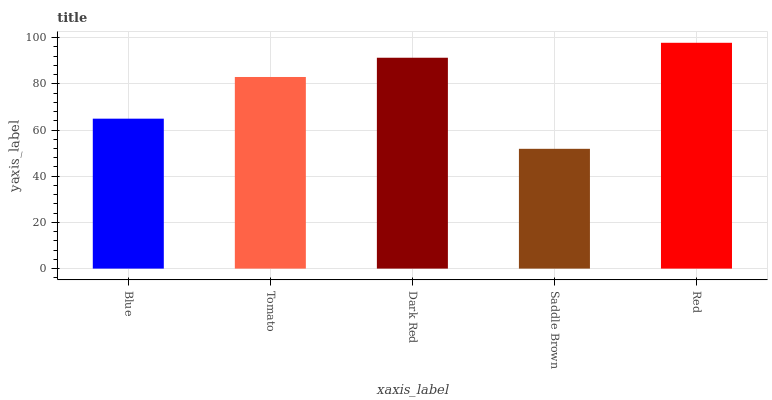Is Saddle Brown the minimum?
Answer yes or no. Yes. Is Red the maximum?
Answer yes or no. Yes. Is Tomato the minimum?
Answer yes or no. No. Is Tomato the maximum?
Answer yes or no. No. Is Tomato greater than Blue?
Answer yes or no. Yes. Is Blue less than Tomato?
Answer yes or no. Yes. Is Blue greater than Tomato?
Answer yes or no. No. Is Tomato less than Blue?
Answer yes or no. No. Is Tomato the high median?
Answer yes or no. Yes. Is Tomato the low median?
Answer yes or no. Yes. Is Dark Red the high median?
Answer yes or no. No. Is Red the low median?
Answer yes or no. No. 